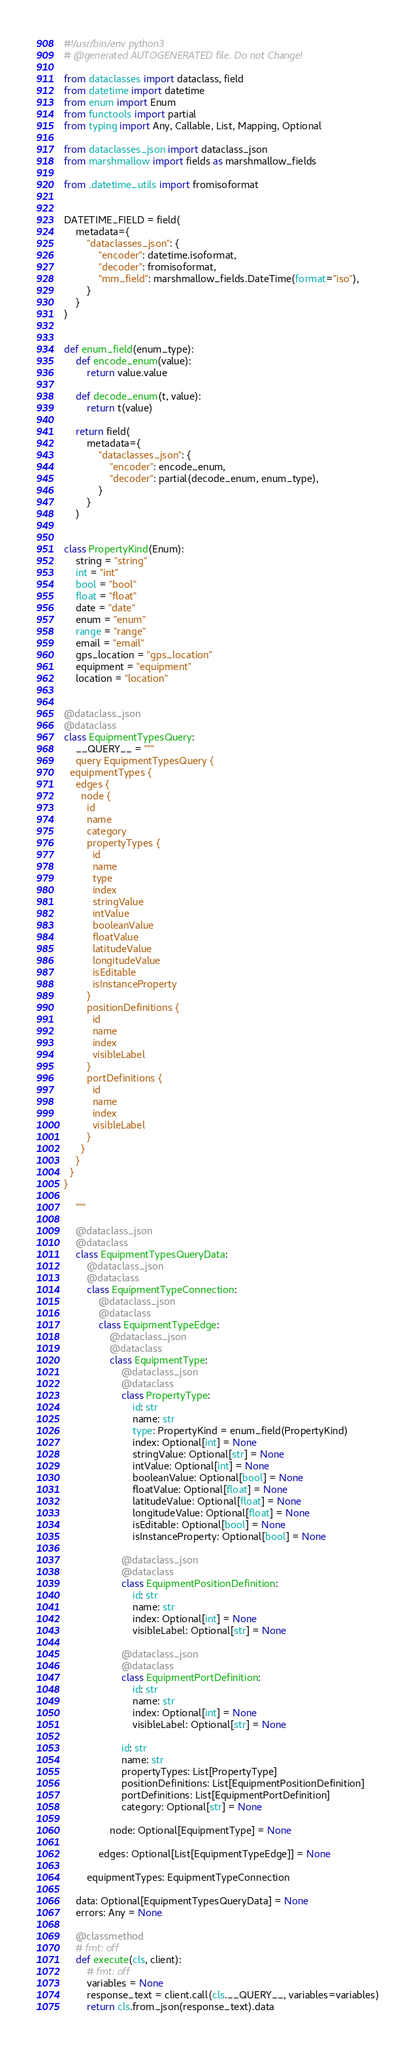<code> <loc_0><loc_0><loc_500><loc_500><_Python_>#!/usr/bin/env python3
# @generated AUTOGENERATED file. Do not Change!

from dataclasses import dataclass, field
from datetime import datetime
from enum import Enum
from functools import partial
from typing import Any, Callable, List, Mapping, Optional

from dataclasses_json import dataclass_json
from marshmallow import fields as marshmallow_fields

from .datetime_utils import fromisoformat


DATETIME_FIELD = field(
    metadata={
        "dataclasses_json": {
            "encoder": datetime.isoformat,
            "decoder": fromisoformat,
            "mm_field": marshmallow_fields.DateTime(format="iso"),
        }
    }
)


def enum_field(enum_type):
    def encode_enum(value):
        return value.value

    def decode_enum(t, value):
        return t(value)

    return field(
        metadata={
            "dataclasses_json": {
                "encoder": encode_enum,
                "decoder": partial(decode_enum, enum_type),
            }
        }
    )


class PropertyKind(Enum):
    string = "string"
    int = "int"
    bool = "bool"
    float = "float"
    date = "date"
    enum = "enum"
    range = "range"
    email = "email"
    gps_location = "gps_location"
    equipment = "equipment"
    location = "location"


@dataclass_json
@dataclass
class EquipmentTypesQuery:
    __QUERY__ = """
    query EquipmentTypesQuery {
  equipmentTypes {
    edges {
      node {
        id
        name
        category
        propertyTypes {
          id
          name
          type
          index
          stringValue
          intValue
          booleanValue
          floatValue
          latitudeValue
          longitudeValue
          isEditable
          isInstanceProperty
        }
        positionDefinitions {
          id
          name
          index
          visibleLabel
        }
        portDefinitions {
          id
          name
          index
          visibleLabel
        }
      }
    }
  }
}

    """

    @dataclass_json
    @dataclass
    class EquipmentTypesQueryData:
        @dataclass_json
        @dataclass
        class EquipmentTypeConnection:
            @dataclass_json
            @dataclass
            class EquipmentTypeEdge:
                @dataclass_json
                @dataclass
                class EquipmentType:
                    @dataclass_json
                    @dataclass
                    class PropertyType:
                        id: str
                        name: str
                        type: PropertyKind = enum_field(PropertyKind)
                        index: Optional[int] = None
                        stringValue: Optional[str] = None
                        intValue: Optional[int] = None
                        booleanValue: Optional[bool] = None
                        floatValue: Optional[float] = None
                        latitudeValue: Optional[float] = None
                        longitudeValue: Optional[float] = None
                        isEditable: Optional[bool] = None
                        isInstanceProperty: Optional[bool] = None

                    @dataclass_json
                    @dataclass
                    class EquipmentPositionDefinition:
                        id: str
                        name: str
                        index: Optional[int] = None
                        visibleLabel: Optional[str] = None

                    @dataclass_json
                    @dataclass
                    class EquipmentPortDefinition:
                        id: str
                        name: str
                        index: Optional[int] = None
                        visibleLabel: Optional[str] = None

                    id: str
                    name: str
                    propertyTypes: List[PropertyType]
                    positionDefinitions: List[EquipmentPositionDefinition]
                    portDefinitions: List[EquipmentPortDefinition]
                    category: Optional[str] = None

                node: Optional[EquipmentType] = None

            edges: Optional[List[EquipmentTypeEdge]] = None

        equipmentTypes: EquipmentTypeConnection

    data: Optional[EquipmentTypesQueryData] = None
    errors: Any = None

    @classmethod
    # fmt: off
    def execute(cls, client):
        # fmt: off
        variables = None
        response_text = client.call(cls.__QUERY__, variables=variables)
        return cls.from_json(response_text).data
</code> 